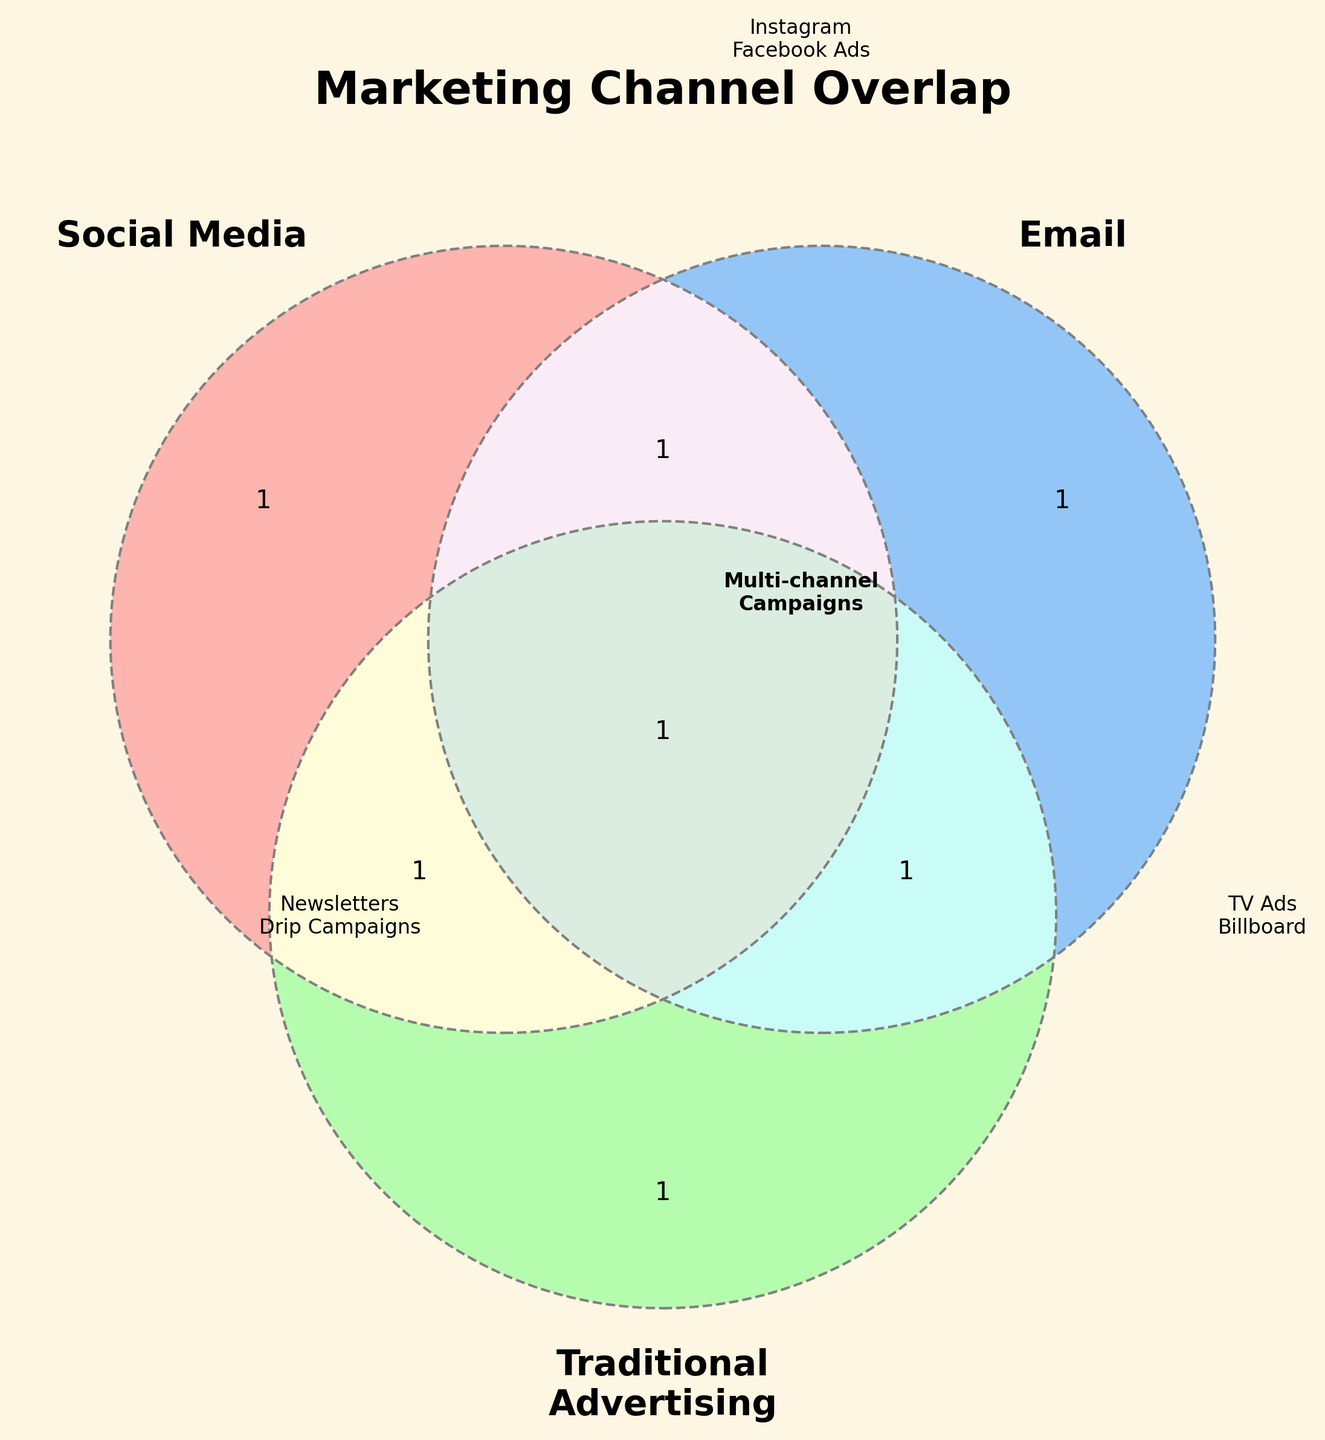what are the three marketing channels shown in the Venn diagram? The Venn diagram indicates three overlapping circles, each labeled with a marketing channel: Social Media, Email, and Traditional Advertising.
Answer: Social Media, Email, Traditional Advertising What is the color of the circle representing Email? The circle representing Email is colored blue. All three circles have distinct colors for easy differentiation.
Answer: Blue Which marketing channel(s) are involved in Multi-channel Campaigns? The Venn diagram shows that Multi-channel Campaigns fall in the region where the circles for Social Media, Email, and Traditional Advertising intersect.
Answer: Social Media, Email, Traditional Advertising Which digital advertising example is mentioned in the Social Media circle? In the Social Media circle, two examples are mentioned: Instagram and Facebook Ads.
Answer: Instagram, Facebook Ads How many traditional advertising examples are listed in the respective circle? The Traditional Advertising circle lists two examples: TV Ads and Billboard.
Answer: Two What labels are included in the section where only Email marketing channels are present? The section of the Venn diagram for only Email marketing channels lists Newsletters and Drip Campaigns.
Answer: Newsletters, Drip Campaigns Which section of the Venn diagram includes Customer Segmentation? Customer Segmentation is part of the overlapping section, suggesting involvement from Social Media, Email, and Traditional Advertising.
Answer: Social Media, Email, Traditional Advertising Compare the examples listed in the Social Media and Traditional Advertising circles. Which circle has more labeled examples? The Social Media circle lists two labeled examples: Instagram and Facebook Ads. The Traditional Advertising circle also lists two examples: TV Ads and Billboard. Therefore, both circles have equal numbers of labeled examples.
Answer: Equal Identify any marketing channel that does not have overlap with the others. The examples not listed in the overlapping sections are: Pinterest and YouTube for Social Media.
Answer: Pinterest, YouTube 